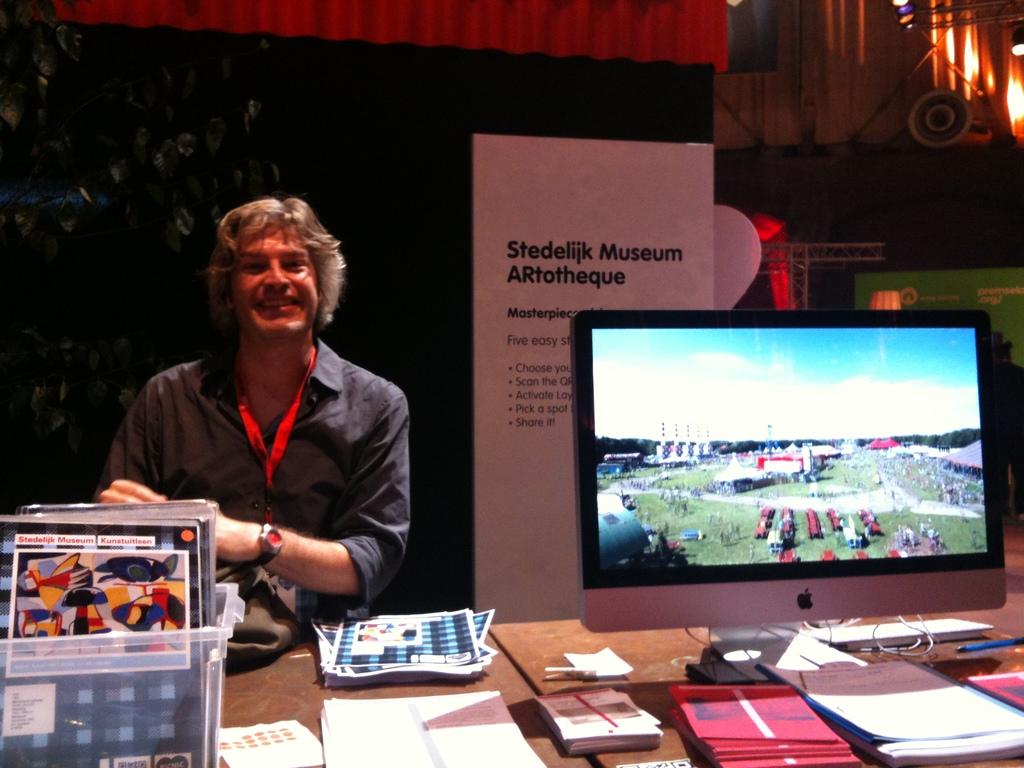The writing behind him is too far to read, what does it say?
Give a very brief answer. Stedelijk museum artotheque. How many steps are listed on the sign?
Ensure brevity in your answer.  5. 